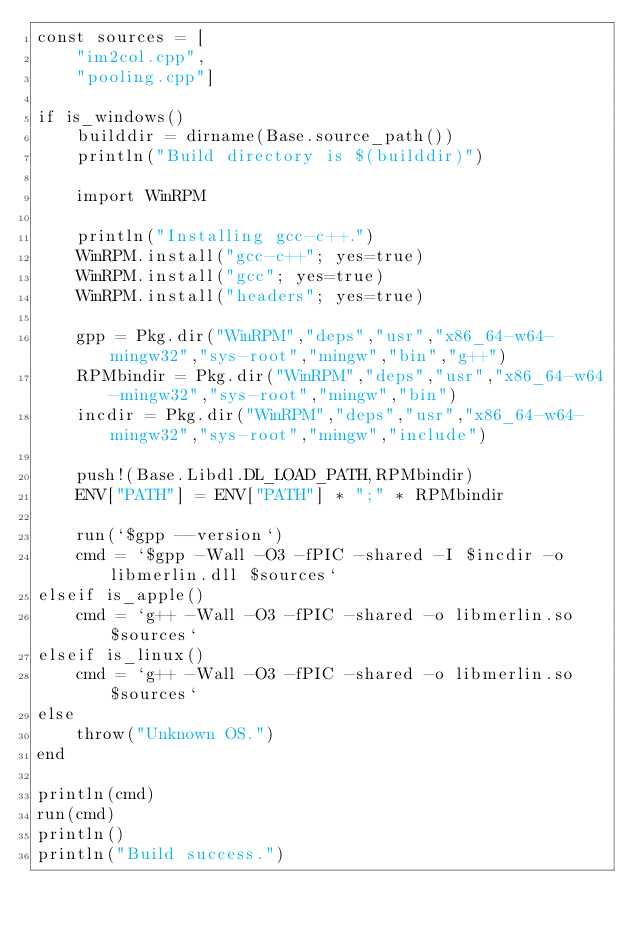<code> <loc_0><loc_0><loc_500><loc_500><_Julia_>const sources = [
    "im2col.cpp",
    "pooling.cpp"]

if is_windows()
    builddir = dirname(Base.source_path())
    println("Build directory is $(builddir)")

    import WinRPM

    println("Installing gcc-c++.")
    WinRPM.install("gcc-c++"; yes=true)
    WinRPM.install("gcc"; yes=true)
    WinRPM.install("headers"; yes=true)

    gpp = Pkg.dir("WinRPM","deps","usr","x86_64-w64-mingw32","sys-root","mingw","bin","g++")
    RPMbindir = Pkg.dir("WinRPM","deps","usr","x86_64-w64-mingw32","sys-root","mingw","bin")
    incdir = Pkg.dir("WinRPM","deps","usr","x86_64-w64-mingw32","sys-root","mingw","include")

    push!(Base.Libdl.DL_LOAD_PATH,RPMbindir)
    ENV["PATH"] = ENV["PATH"] * ";" * RPMbindir

    run(`$gpp --version`)
    cmd = `$gpp -Wall -O3 -fPIC -shared -I $incdir -o libmerlin.dll $sources`
elseif is_apple()
    cmd = `g++ -Wall -O3 -fPIC -shared -o libmerlin.so $sources`
elseif is_linux()
    cmd = `g++ -Wall -O3 -fPIC -shared -o libmerlin.so $sources`
else
    throw("Unknown OS.")
end

println(cmd)
run(cmd)
println()
println("Build success.")
</code> 